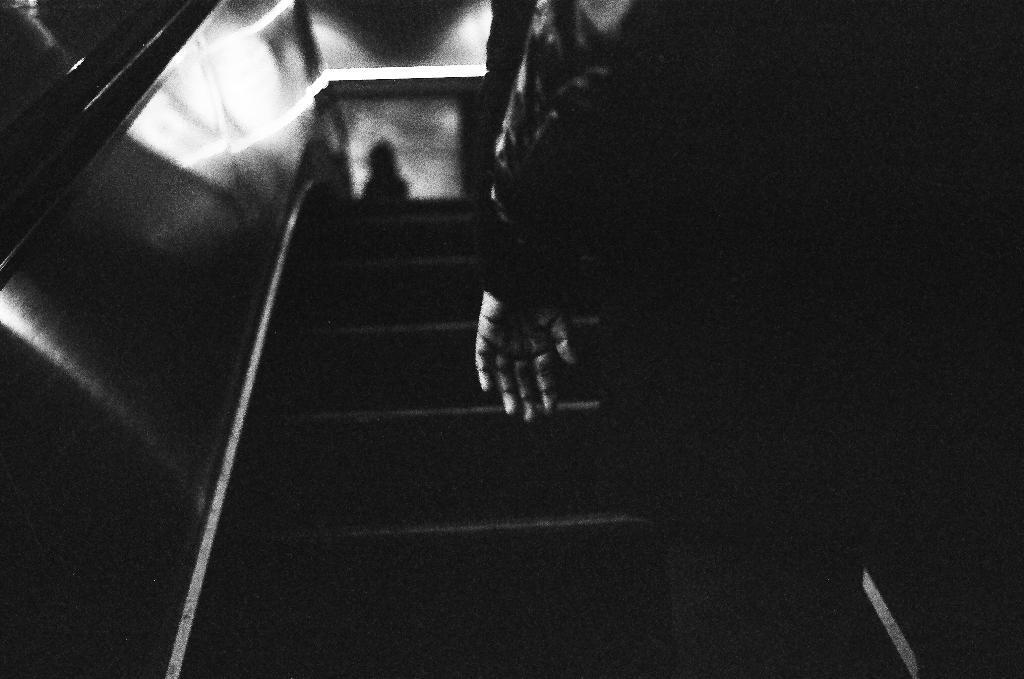Could you give a brief overview of what you see in this image? This is a black and white picture, there is a person standing on the escalator. 